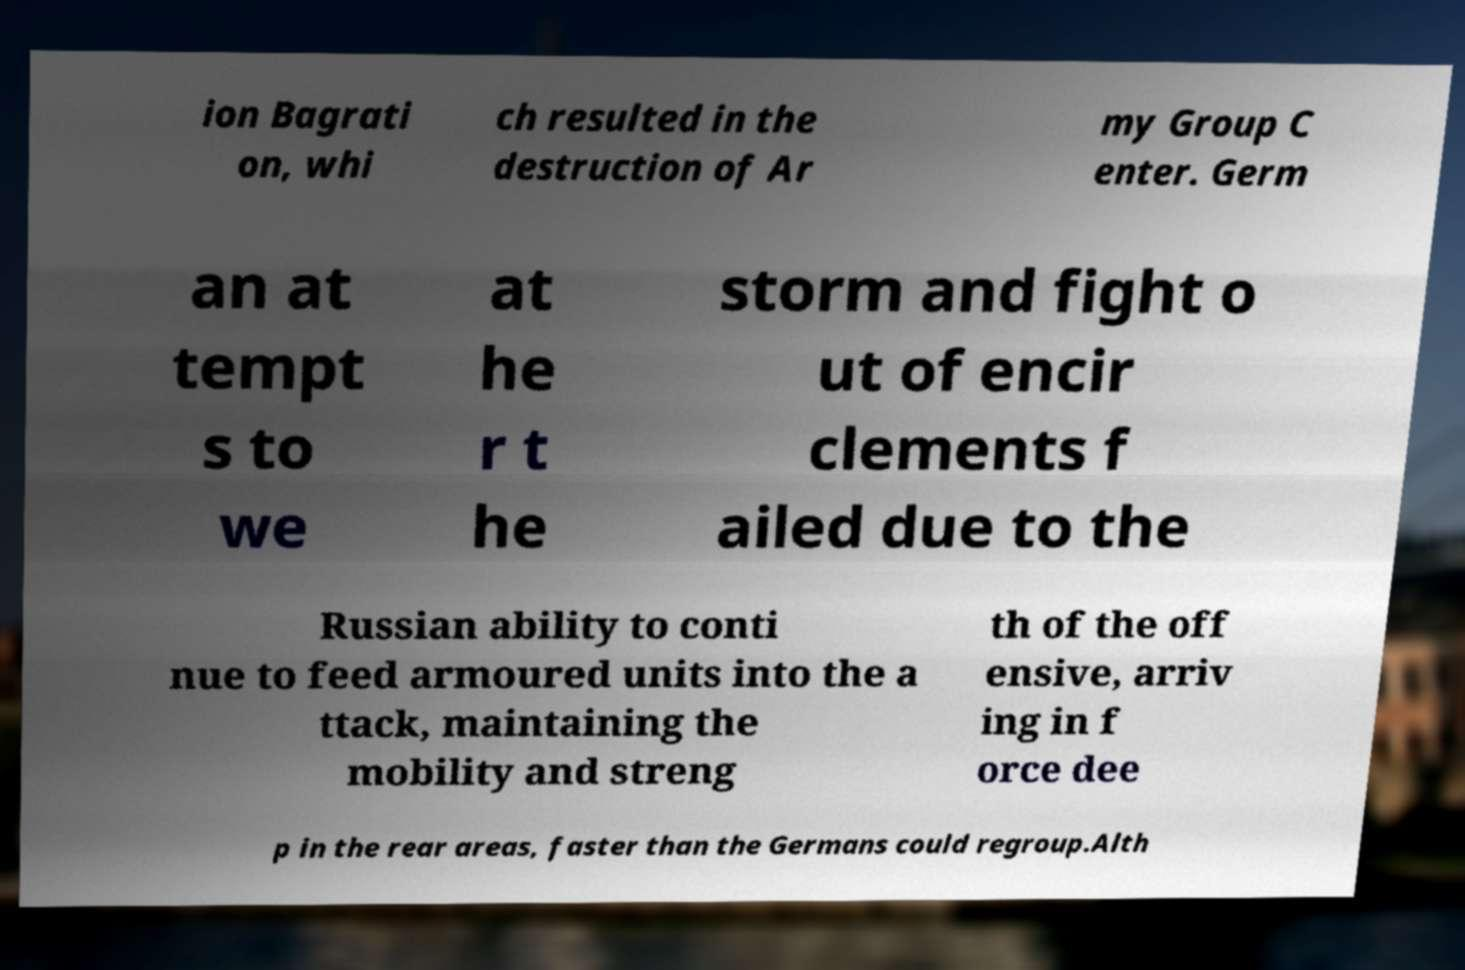I need the written content from this picture converted into text. Can you do that? ion Bagrati on, whi ch resulted in the destruction of Ar my Group C enter. Germ an at tempt s to we at he r t he storm and fight o ut of encir clements f ailed due to the Russian ability to conti nue to feed armoured units into the a ttack, maintaining the mobility and streng th of the off ensive, arriv ing in f orce dee p in the rear areas, faster than the Germans could regroup.Alth 